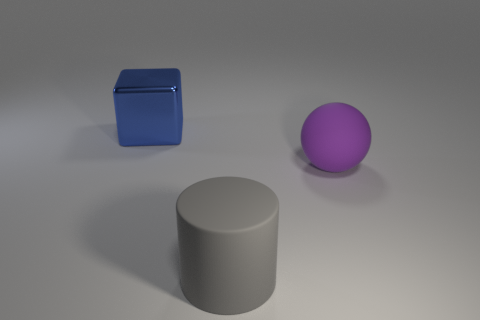There is a object behind the large rubber thing that is behind the matte object in front of the sphere; what is its color?
Offer a very short reply. Blue. Does the big cylinder have the same material as the large purple thing?
Your answer should be very brief. Yes. How many big blue things are behind the purple ball?
Offer a terse response. 1. What number of green objects are small metallic cubes or big cubes?
Offer a terse response. 0. There is a large rubber object left of the purple object; what number of big purple objects are behind it?
Make the answer very short. 1. How many other things are there of the same shape as the purple matte object?
Your answer should be very brief. 0. There is a thing that is the same material as the big gray cylinder; what is its color?
Your answer should be compact. Purple. Are there any gray matte cylinders that have the same size as the blue metallic object?
Provide a short and direct response. Yes. Are there more big matte balls behind the big cylinder than blue shiny blocks on the right side of the big blue shiny cube?
Your answer should be compact. Yes. Is the object in front of the big purple rubber sphere made of the same material as the large sphere that is right of the gray rubber cylinder?
Your response must be concise. Yes. 